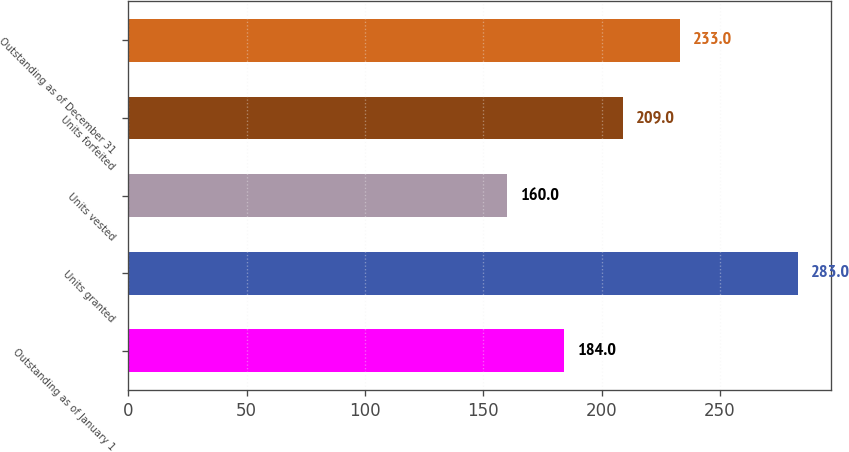Convert chart to OTSL. <chart><loc_0><loc_0><loc_500><loc_500><bar_chart><fcel>Outstanding as of January 1<fcel>Units granted<fcel>Units vested<fcel>Units forfeited<fcel>Outstanding as of December 31<nl><fcel>184<fcel>283<fcel>160<fcel>209<fcel>233<nl></chart> 